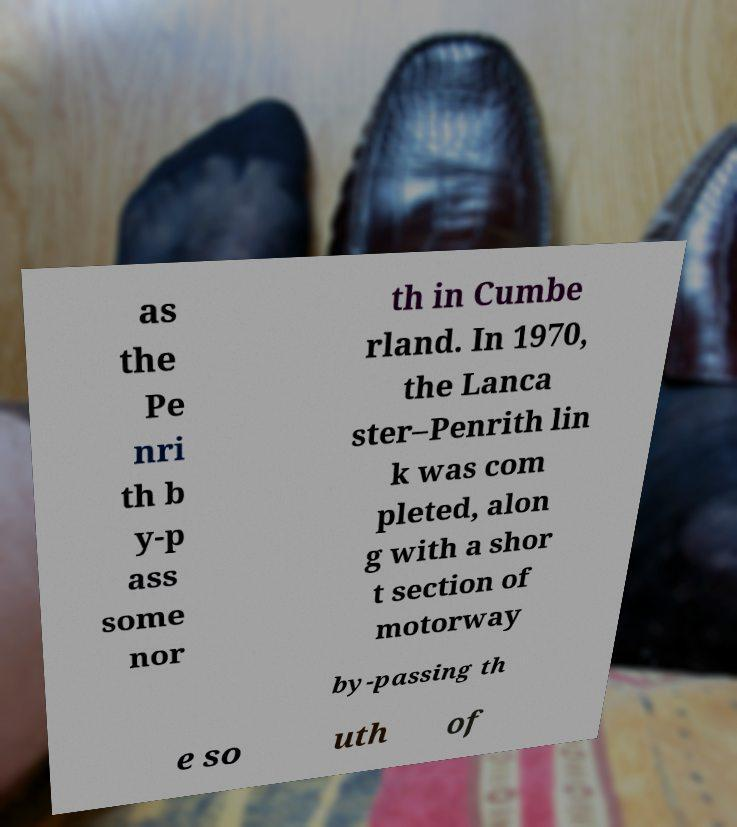There's text embedded in this image that I need extracted. Can you transcribe it verbatim? as the Pe nri th b y-p ass some nor th in Cumbe rland. In 1970, the Lanca ster–Penrith lin k was com pleted, alon g with a shor t section of motorway by-passing th e so uth of 